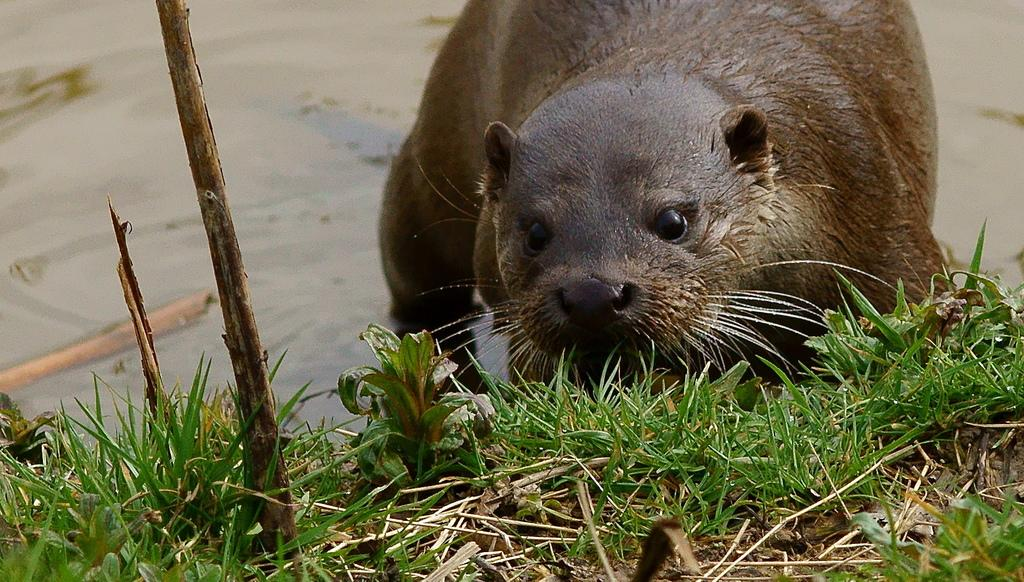What is in the water in the image? There is an animal in the water in the image. What object can be seen in the image besides the animal? There is a stick visible in the image. What type of vegetation is present in the image? There is grass in the image. Can you describe the possible location of the image? The image may have been taken near a lake, given the presence of water and grass. How many pictures are hanging on the wall in the image? There is no mention of any pictures or walls in the image; it features an animal in the water, a stick, and grass. 